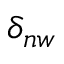Convert formula to latex. <formula><loc_0><loc_0><loc_500><loc_500>\delta _ { n w }</formula> 